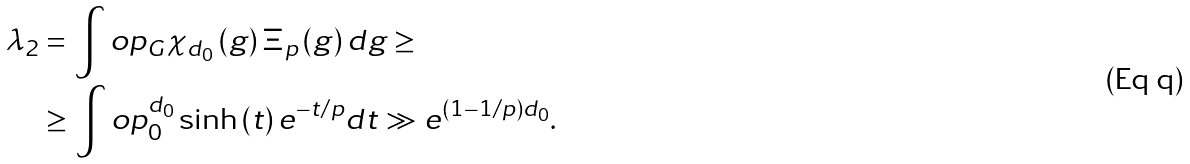Convert formula to latex. <formula><loc_0><loc_0><loc_500><loc_500>\lambda _ { 2 } & = \int o p _ { G } \chi _ { d _ { 0 } } \left ( g \right ) \Xi _ { p } \left ( g \right ) d g \geq \\ & \geq \int o p _ { 0 } ^ { d _ { 0 } } \sinh \left ( t \right ) e ^ { - t / p } d t \gg e ^ { \left ( 1 - 1 / p \right ) d _ { 0 } } .</formula> 